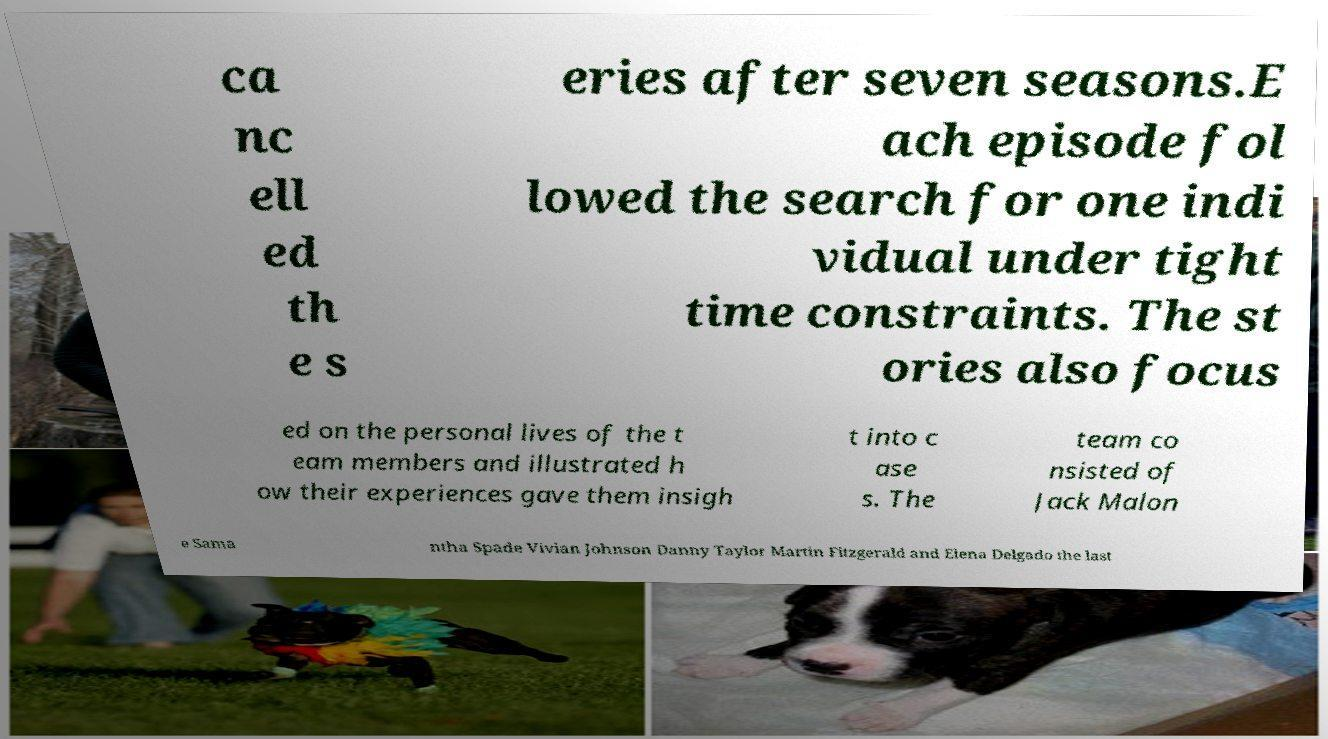Can you accurately transcribe the text from the provided image for me? ca nc ell ed th e s eries after seven seasons.E ach episode fol lowed the search for one indi vidual under tight time constraints. The st ories also focus ed on the personal lives of the t eam members and illustrated h ow their experiences gave them insigh t into c ase s. The team co nsisted of Jack Malon e Sama ntha Spade Vivian Johnson Danny Taylor Martin Fitzgerald and Elena Delgado the last 